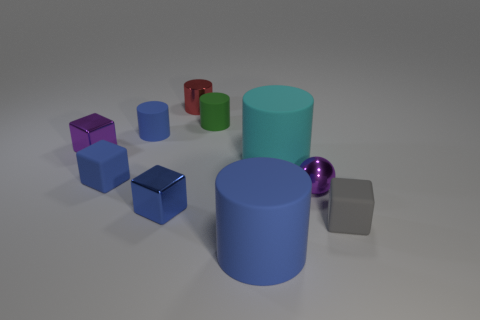There is a blue matte cylinder that is behind the gray block; is there a purple ball behind it?
Your answer should be very brief. No. What number of other objects are the same color as the metallic cylinder?
Ensure brevity in your answer.  0. Is the size of the rubber thing that is on the right side of the sphere the same as the blue matte cylinder behind the big cyan cylinder?
Make the answer very short. Yes. There is a matte cylinder that is in front of the metallic object that is right of the cyan rubber object; how big is it?
Your answer should be very brief. Large. What material is the cube that is in front of the small ball and left of the metal cylinder?
Ensure brevity in your answer.  Metal. What color is the shiny cylinder?
Your answer should be compact. Red. Is there any other thing that has the same material as the small gray block?
Provide a short and direct response. Yes. The blue rubber thing that is in front of the gray thing has what shape?
Offer a terse response. Cylinder. Are there any tiny cubes that are behind the tiny blue block in front of the purple shiny object that is in front of the small purple metal cube?
Your answer should be very brief. Yes. Are there any other things that have the same shape as the tiny blue shiny object?
Your answer should be very brief. Yes. 